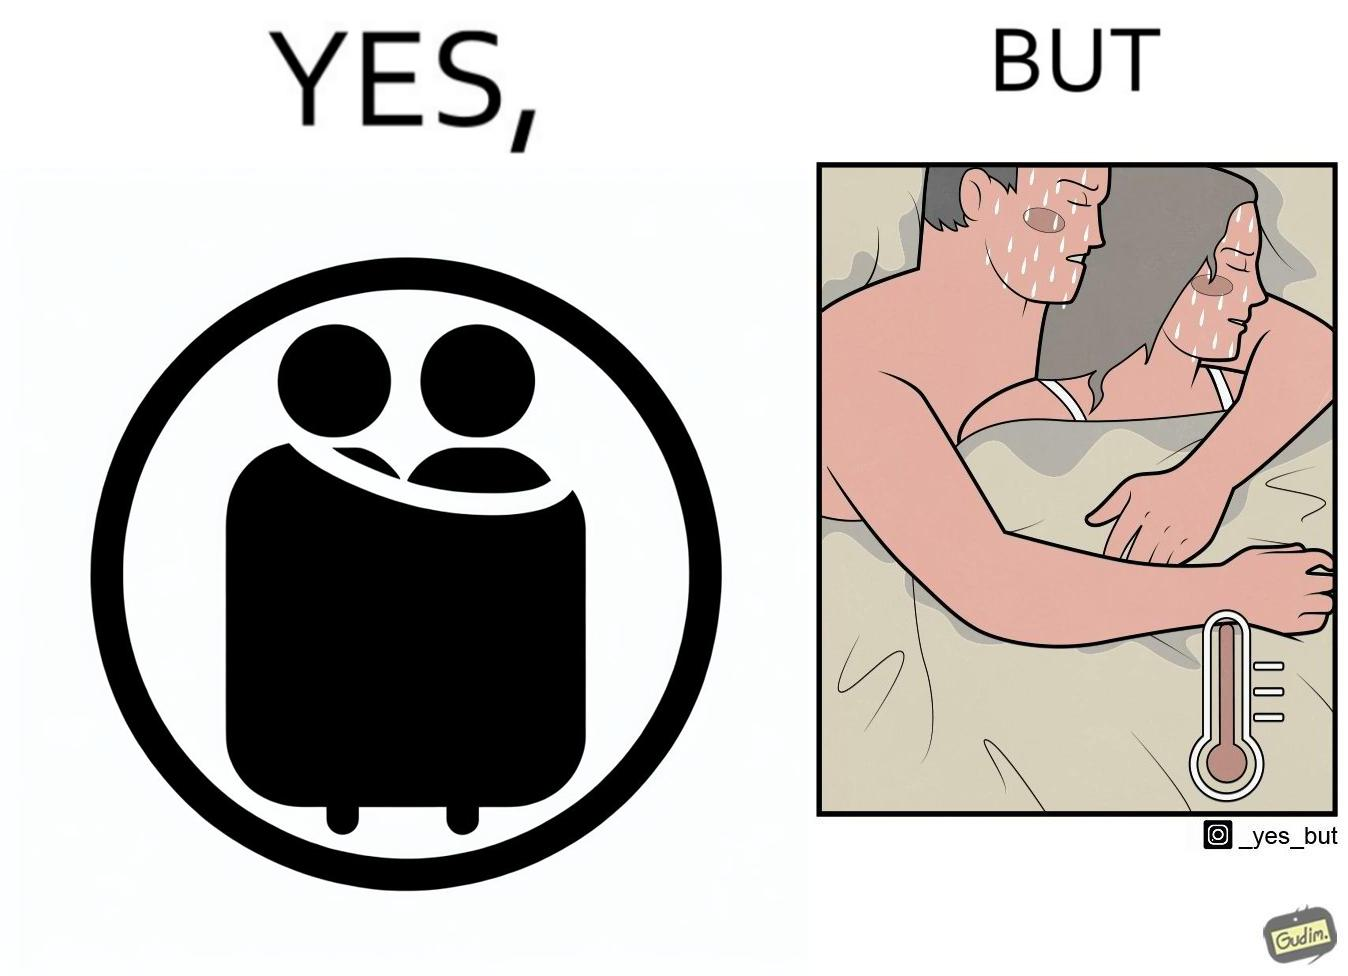Why is this image considered satirical? The image is ironic, because after some time cuddling within a blanket raises the temperature which leads to inconvenience 